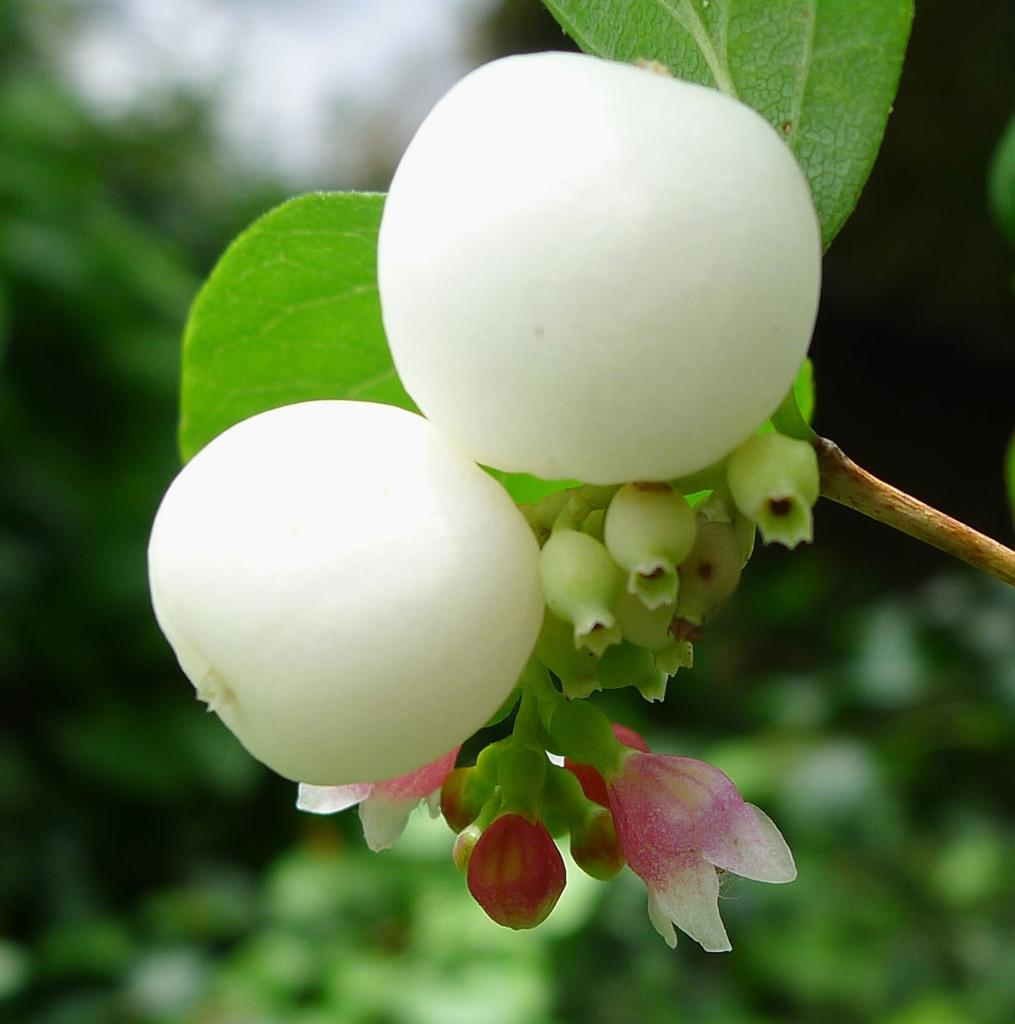What type of plant elements can be seen in the image? There are buds and leaves in the image. Can you describe the background of the image? The background of the image is blurred. What type of bell can be seen in the image? There is no bell present in the image; it features buds and leaves. What color is the blood on the leaves in the image? There is no blood present in the image; it only features buds and leaves. 